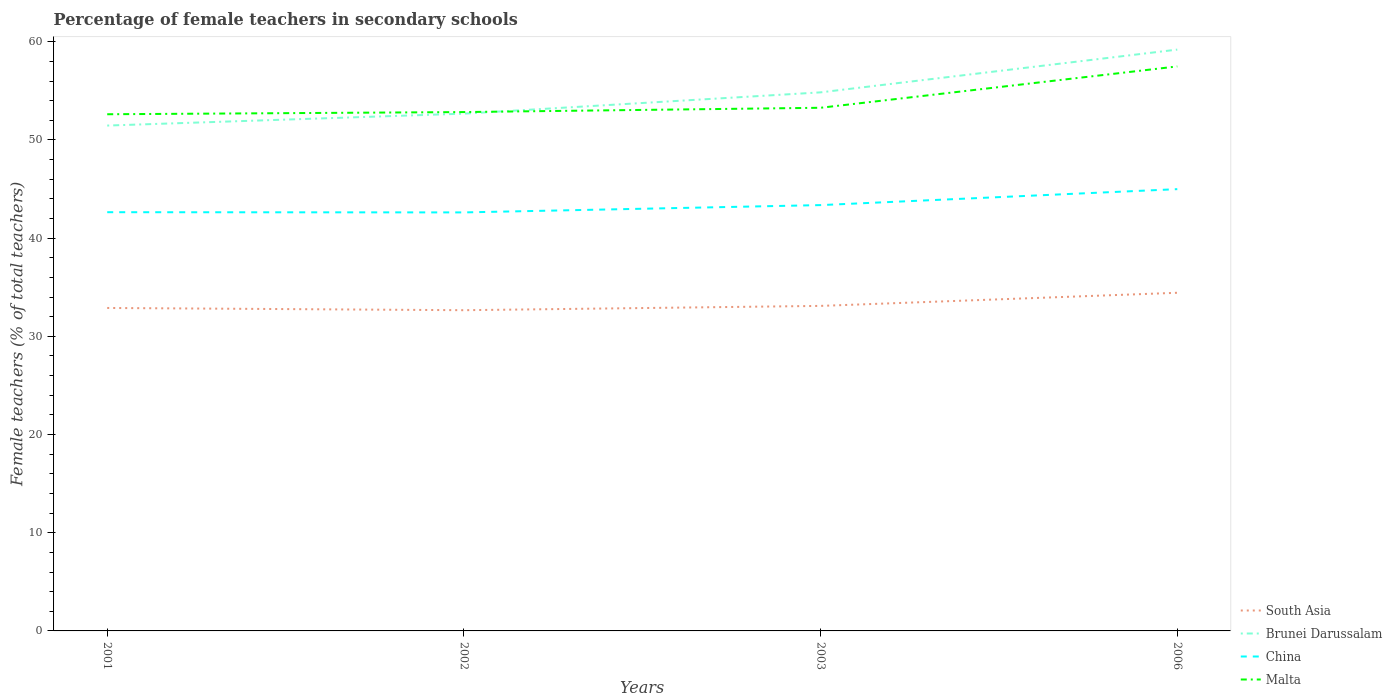How many different coloured lines are there?
Keep it short and to the point. 4. Is the number of lines equal to the number of legend labels?
Offer a very short reply. Yes. Across all years, what is the maximum percentage of female teachers in South Asia?
Your response must be concise. 32.66. What is the total percentage of female teachers in China in the graph?
Provide a short and direct response. -1.62. What is the difference between the highest and the second highest percentage of female teachers in Malta?
Offer a very short reply. 4.87. How many lines are there?
Your answer should be compact. 4. Does the graph contain any zero values?
Your answer should be very brief. No. Does the graph contain grids?
Provide a short and direct response. No. What is the title of the graph?
Give a very brief answer. Percentage of female teachers in secondary schools. Does "Caribbean small states" appear as one of the legend labels in the graph?
Keep it short and to the point. No. What is the label or title of the X-axis?
Your answer should be compact. Years. What is the label or title of the Y-axis?
Give a very brief answer. Female teachers (% of total teachers). What is the Female teachers (% of total teachers) in South Asia in 2001?
Make the answer very short. 32.89. What is the Female teachers (% of total teachers) in Brunei Darussalam in 2001?
Your answer should be compact. 51.47. What is the Female teachers (% of total teachers) in China in 2001?
Ensure brevity in your answer.  42.64. What is the Female teachers (% of total teachers) of Malta in 2001?
Your answer should be compact. 52.62. What is the Female teachers (% of total teachers) of South Asia in 2002?
Your response must be concise. 32.66. What is the Female teachers (% of total teachers) in Brunei Darussalam in 2002?
Your response must be concise. 52.68. What is the Female teachers (% of total teachers) of China in 2002?
Your answer should be very brief. 42.62. What is the Female teachers (% of total teachers) of Malta in 2002?
Provide a short and direct response. 52.84. What is the Female teachers (% of total teachers) in South Asia in 2003?
Provide a succinct answer. 33.1. What is the Female teachers (% of total teachers) in Brunei Darussalam in 2003?
Your answer should be very brief. 54.85. What is the Female teachers (% of total teachers) in China in 2003?
Keep it short and to the point. 43.37. What is the Female teachers (% of total teachers) of Malta in 2003?
Ensure brevity in your answer.  53.28. What is the Female teachers (% of total teachers) of South Asia in 2006?
Offer a terse response. 34.44. What is the Female teachers (% of total teachers) in Brunei Darussalam in 2006?
Offer a terse response. 59.2. What is the Female teachers (% of total teachers) of China in 2006?
Your response must be concise. 44.99. What is the Female teachers (% of total teachers) of Malta in 2006?
Offer a very short reply. 57.49. Across all years, what is the maximum Female teachers (% of total teachers) in South Asia?
Give a very brief answer. 34.44. Across all years, what is the maximum Female teachers (% of total teachers) in Brunei Darussalam?
Offer a very short reply. 59.2. Across all years, what is the maximum Female teachers (% of total teachers) in China?
Provide a succinct answer. 44.99. Across all years, what is the maximum Female teachers (% of total teachers) of Malta?
Ensure brevity in your answer.  57.49. Across all years, what is the minimum Female teachers (% of total teachers) of South Asia?
Offer a terse response. 32.66. Across all years, what is the minimum Female teachers (% of total teachers) in Brunei Darussalam?
Keep it short and to the point. 51.47. Across all years, what is the minimum Female teachers (% of total teachers) of China?
Give a very brief answer. 42.62. Across all years, what is the minimum Female teachers (% of total teachers) of Malta?
Give a very brief answer. 52.62. What is the total Female teachers (% of total teachers) in South Asia in the graph?
Offer a terse response. 133.09. What is the total Female teachers (% of total teachers) of Brunei Darussalam in the graph?
Offer a terse response. 218.19. What is the total Female teachers (% of total teachers) of China in the graph?
Make the answer very short. 173.62. What is the total Female teachers (% of total teachers) in Malta in the graph?
Offer a very short reply. 216.22. What is the difference between the Female teachers (% of total teachers) in South Asia in 2001 and that in 2002?
Ensure brevity in your answer.  0.23. What is the difference between the Female teachers (% of total teachers) of Brunei Darussalam in 2001 and that in 2002?
Provide a short and direct response. -1.21. What is the difference between the Female teachers (% of total teachers) in China in 2001 and that in 2002?
Ensure brevity in your answer.  0.02. What is the difference between the Female teachers (% of total teachers) in Malta in 2001 and that in 2002?
Offer a very short reply. -0.22. What is the difference between the Female teachers (% of total teachers) of South Asia in 2001 and that in 2003?
Keep it short and to the point. -0.21. What is the difference between the Female teachers (% of total teachers) of Brunei Darussalam in 2001 and that in 2003?
Offer a terse response. -3.38. What is the difference between the Female teachers (% of total teachers) of China in 2001 and that in 2003?
Offer a terse response. -0.72. What is the difference between the Female teachers (% of total teachers) of Malta in 2001 and that in 2003?
Your response must be concise. -0.66. What is the difference between the Female teachers (% of total teachers) of South Asia in 2001 and that in 2006?
Ensure brevity in your answer.  -1.55. What is the difference between the Female teachers (% of total teachers) in Brunei Darussalam in 2001 and that in 2006?
Offer a very short reply. -7.74. What is the difference between the Female teachers (% of total teachers) of China in 2001 and that in 2006?
Provide a succinct answer. -2.35. What is the difference between the Female teachers (% of total teachers) of Malta in 2001 and that in 2006?
Make the answer very short. -4.87. What is the difference between the Female teachers (% of total teachers) in South Asia in 2002 and that in 2003?
Provide a short and direct response. -0.44. What is the difference between the Female teachers (% of total teachers) of Brunei Darussalam in 2002 and that in 2003?
Keep it short and to the point. -2.17. What is the difference between the Female teachers (% of total teachers) in China in 2002 and that in 2003?
Keep it short and to the point. -0.74. What is the difference between the Female teachers (% of total teachers) of Malta in 2002 and that in 2003?
Your answer should be very brief. -0.44. What is the difference between the Female teachers (% of total teachers) in South Asia in 2002 and that in 2006?
Provide a short and direct response. -1.77. What is the difference between the Female teachers (% of total teachers) in Brunei Darussalam in 2002 and that in 2006?
Provide a short and direct response. -6.52. What is the difference between the Female teachers (% of total teachers) of China in 2002 and that in 2006?
Your response must be concise. -2.37. What is the difference between the Female teachers (% of total teachers) in Malta in 2002 and that in 2006?
Your response must be concise. -4.65. What is the difference between the Female teachers (% of total teachers) of South Asia in 2003 and that in 2006?
Make the answer very short. -1.34. What is the difference between the Female teachers (% of total teachers) of Brunei Darussalam in 2003 and that in 2006?
Provide a short and direct response. -4.35. What is the difference between the Female teachers (% of total teachers) of China in 2003 and that in 2006?
Ensure brevity in your answer.  -1.62. What is the difference between the Female teachers (% of total teachers) in Malta in 2003 and that in 2006?
Ensure brevity in your answer.  -4.21. What is the difference between the Female teachers (% of total teachers) in South Asia in 2001 and the Female teachers (% of total teachers) in Brunei Darussalam in 2002?
Offer a very short reply. -19.79. What is the difference between the Female teachers (% of total teachers) in South Asia in 2001 and the Female teachers (% of total teachers) in China in 2002?
Ensure brevity in your answer.  -9.73. What is the difference between the Female teachers (% of total teachers) in South Asia in 2001 and the Female teachers (% of total teachers) in Malta in 2002?
Keep it short and to the point. -19.95. What is the difference between the Female teachers (% of total teachers) of Brunei Darussalam in 2001 and the Female teachers (% of total teachers) of China in 2002?
Give a very brief answer. 8.84. What is the difference between the Female teachers (% of total teachers) of Brunei Darussalam in 2001 and the Female teachers (% of total teachers) of Malta in 2002?
Make the answer very short. -1.37. What is the difference between the Female teachers (% of total teachers) of China in 2001 and the Female teachers (% of total teachers) of Malta in 2002?
Make the answer very short. -10.2. What is the difference between the Female teachers (% of total teachers) of South Asia in 2001 and the Female teachers (% of total teachers) of Brunei Darussalam in 2003?
Provide a succinct answer. -21.96. What is the difference between the Female teachers (% of total teachers) in South Asia in 2001 and the Female teachers (% of total teachers) in China in 2003?
Offer a very short reply. -10.48. What is the difference between the Female teachers (% of total teachers) in South Asia in 2001 and the Female teachers (% of total teachers) in Malta in 2003?
Your response must be concise. -20.39. What is the difference between the Female teachers (% of total teachers) in Brunei Darussalam in 2001 and the Female teachers (% of total teachers) in China in 2003?
Your answer should be compact. 8.1. What is the difference between the Female teachers (% of total teachers) of Brunei Darussalam in 2001 and the Female teachers (% of total teachers) of Malta in 2003?
Offer a terse response. -1.81. What is the difference between the Female teachers (% of total teachers) of China in 2001 and the Female teachers (% of total teachers) of Malta in 2003?
Your answer should be compact. -10.63. What is the difference between the Female teachers (% of total teachers) in South Asia in 2001 and the Female teachers (% of total teachers) in Brunei Darussalam in 2006?
Provide a succinct answer. -26.31. What is the difference between the Female teachers (% of total teachers) of South Asia in 2001 and the Female teachers (% of total teachers) of China in 2006?
Your answer should be very brief. -12.1. What is the difference between the Female teachers (% of total teachers) in South Asia in 2001 and the Female teachers (% of total teachers) in Malta in 2006?
Your response must be concise. -24.6. What is the difference between the Female teachers (% of total teachers) of Brunei Darussalam in 2001 and the Female teachers (% of total teachers) of China in 2006?
Make the answer very short. 6.48. What is the difference between the Female teachers (% of total teachers) of Brunei Darussalam in 2001 and the Female teachers (% of total teachers) of Malta in 2006?
Ensure brevity in your answer.  -6.02. What is the difference between the Female teachers (% of total teachers) of China in 2001 and the Female teachers (% of total teachers) of Malta in 2006?
Your answer should be compact. -14.85. What is the difference between the Female teachers (% of total teachers) in South Asia in 2002 and the Female teachers (% of total teachers) in Brunei Darussalam in 2003?
Your response must be concise. -22.19. What is the difference between the Female teachers (% of total teachers) in South Asia in 2002 and the Female teachers (% of total teachers) in China in 2003?
Offer a very short reply. -10.7. What is the difference between the Female teachers (% of total teachers) of South Asia in 2002 and the Female teachers (% of total teachers) of Malta in 2003?
Your answer should be compact. -20.61. What is the difference between the Female teachers (% of total teachers) of Brunei Darussalam in 2002 and the Female teachers (% of total teachers) of China in 2003?
Make the answer very short. 9.31. What is the difference between the Female teachers (% of total teachers) in Brunei Darussalam in 2002 and the Female teachers (% of total teachers) in Malta in 2003?
Your response must be concise. -0.6. What is the difference between the Female teachers (% of total teachers) in China in 2002 and the Female teachers (% of total teachers) in Malta in 2003?
Your answer should be compact. -10.66. What is the difference between the Female teachers (% of total teachers) of South Asia in 2002 and the Female teachers (% of total teachers) of Brunei Darussalam in 2006?
Keep it short and to the point. -26.54. What is the difference between the Female teachers (% of total teachers) of South Asia in 2002 and the Female teachers (% of total teachers) of China in 2006?
Ensure brevity in your answer.  -12.33. What is the difference between the Female teachers (% of total teachers) in South Asia in 2002 and the Female teachers (% of total teachers) in Malta in 2006?
Make the answer very short. -24.83. What is the difference between the Female teachers (% of total teachers) in Brunei Darussalam in 2002 and the Female teachers (% of total teachers) in China in 2006?
Provide a succinct answer. 7.69. What is the difference between the Female teachers (% of total teachers) in Brunei Darussalam in 2002 and the Female teachers (% of total teachers) in Malta in 2006?
Offer a terse response. -4.81. What is the difference between the Female teachers (% of total teachers) in China in 2002 and the Female teachers (% of total teachers) in Malta in 2006?
Give a very brief answer. -14.87. What is the difference between the Female teachers (% of total teachers) of South Asia in 2003 and the Female teachers (% of total teachers) of Brunei Darussalam in 2006?
Your answer should be compact. -26.1. What is the difference between the Female teachers (% of total teachers) of South Asia in 2003 and the Female teachers (% of total teachers) of China in 2006?
Your response must be concise. -11.89. What is the difference between the Female teachers (% of total teachers) in South Asia in 2003 and the Female teachers (% of total teachers) in Malta in 2006?
Offer a terse response. -24.39. What is the difference between the Female teachers (% of total teachers) in Brunei Darussalam in 2003 and the Female teachers (% of total teachers) in China in 2006?
Provide a short and direct response. 9.86. What is the difference between the Female teachers (% of total teachers) of Brunei Darussalam in 2003 and the Female teachers (% of total teachers) of Malta in 2006?
Offer a terse response. -2.64. What is the difference between the Female teachers (% of total teachers) in China in 2003 and the Female teachers (% of total teachers) in Malta in 2006?
Make the answer very short. -14.12. What is the average Female teachers (% of total teachers) in South Asia per year?
Make the answer very short. 33.27. What is the average Female teachers (% of total teachers) in Brunei Darussalam per year?
Offer a terse response. 54.55. What is the average Female teachers (% of total teachers) of China per year?
Offer a terse response. 43.41. What is the average Female teachers (% of total teachers) in Malta per year?
Offer a very short reply. 54.06. In the year 2001, what is the difference between the Female teachers (% of total teachers) in South Asia and Female teachers (% of total teachers) in Brunei Darussalam?
Make the answer very short. -18.58. In the year 2001, what is the difference between the Female teachers (% of total teachers) in South Asia and Female teachers (% of total teachers) in China?
Keep it short and to the point. -9.75. In the year 2001, what is the difference between the Female teachers (% of total teachers) of South Asia and Female teachers (% of total teachers) of Malta?
Provide a short and direct response. -19.73. In the year 2001, what is the difference between the Female teachers (% of total teachers) of Brunei Darussalam and Female teachers (% of total teachers) of China?
Provide a short and direct response. 8.82. In the year 2001, what is the difference between the Female teachers (% of total teachers) in Brunei Darussalam and Female teachers (% of total teachers) in Malta?
Your answer should be compact. -1.15. In the year 2001, what is the difference between the Female teachers (% of total teachers) of China and Female teachers (% of total teachers) of Malta?
Give a very brief answer. -9.97. In the year 2002, what is the difference between the Female teachers (% of total teachers) of South Asia and Female teachers (% of total teachers) of Brunei Darussalam?
Offer a terse response. -20.02. In the year 2002, what is the difference between the Female teachers (% of total teachers) in South Asia and Female teachers (% of total teachers) in China?
Provide a succinct answer. -9.96. In the year 2002, what is the difference between the Female teachers (% of total teachers) in South Asia and Female teachers (% of total teachers) in Malta?
Make the answer very short. -20.18. In the year 2002, what is the difference between the Female teachers (% of total teachers) in Brunei Darussalam and Female teachers (% of total teachers) in China?
Make the answer very short. 10.06. In the year 2002, what is the difference between the Female teachers (% of total teachers) of Brunei Darussalam and Female teachers (% of total teachers) of Malta?
Ensure brevity in your answer.  -0.16. In the year 2002, what is the difference between the Female teachers (% of total teachers) in China and Female teachers (% of total teachers) in Malta?
Ensure brevity in your answer.  -10.22. In the year 2003, what is the difference between the Female teachers (% of total teachers) in South Asia and Female teachers (% of total teachers) in Brunei Darussalam?
Give a very brief answer. -21.75. In the year 2003, what is the difference between the Female teachers (% of total teachers) of South Asia and Female teachers (% of total teachers) of China?
Your answer should be compact. -10.27. In the year 2003, what is the difference between the Female teachers (% of total teachers) of South Asia and Female teachers (% of total teachers) of Malta?
Provide a short and direct response. -20.18. In the year 2003, what is the difference between the Female teachers (% of total teachers) in Brunei Darussalam and Female teachers (% of total teachers) in China?
Your answer should be compact. 11.48. In the year 2003, what is the difference between the Female teachers (% of total teachers) in Brunei Darussalam and Female teachers (% of total teachers) in Malta?
Ensure brevity in your answer.  1.57. In the year 2003, what is the difference between the Female teachers (% of total teachers) in China and Female teachers (% of total teachers) in Malta?
Your answer should be compact. -9.91. In the year 2006, what is the difference between the Female teachers (% of total teachers) of South Asia and Female teachers (% of total teachers) of Brunei Darussalam?
Offer a terse response. -24.76. In the year 2006, what is the difference between the Female teachers (% of total teachers) of South Asia and Female teachers (% of total teachers) of China?
Provide a short and direct response. -10.55. In the year 2006, what is the difference between the Female teachers (% of total teachers) in South Asia and Female teachers (% of total teachers) in Malta?
Keep it short and to the point. -23.05. In the year 2006, what is the difference between the Female teachers (% of total teachers) of Brunei Darussalam and Female teachers (% of total teachers) of China?
Your response must be concise. 14.21. In the year 2006, what is the difference between the Female teachers (% of total teachers) of Brunei Darussalam and Female teachers (% of total teachers) of Malta?
Provide a succinct answer. 1.71. In the year 2006, what is the difference between the Female teachers (% of total teachers) in China and Female teachers (% of total teachers) in Malta?
Offer a terse response. -12.5. What is the ratio of the Female teachers (% of total teachers) in South Asia in 2001 to that in 2002?
Offer a terse response. 1.01. What is the ratio of the Female teachers (% of total teachers) in China in 2001 to that in 2002?
Your answer should be very brief. 1. What is the ratio of the Female teachers (% of total teachers) in Malta in 2001 to that in 2002?
Your response must be concise. 1. What is the ratio of the Female teachers (% of total teachers) in Brunei Darussalam in 2001 to that in 2003?
Your response must be concise. 0.94. What is the ratio of the Female teachers (% of total teachers) of China in 2001 to that in 2003?
Give a very brief answer. 0.98. What is the ratio of the Female teachers (% of total teachers) in Malta in 2001 to that in 2003?
Keep it short and to the point. 0.99. What is the ratio of the Female teachers (% of total teachers) of South Asia in 2001 to that in 2006?
Provide a succinct answer. 0.96. What is the ratio of the Female teachers (% of total teachers) of Brunei Darussalam in 2001 to that in 2006?
Offer a very short reply. 0.87. What is the ratio of the Female teachers (% of total teachers) in China in 2001 to that in 2006?
Offer a very short reply. 0.95. What is the ratio of the Female teachers (% of total teachers) in Malta in 2001 to that in 2006?
Provide a short and direct response. 0.92. What is the ratio of the Female teachers (% of total teachers) of South Asia in 2002 to that in 2003?
Your answer should be very brief. 0.99. What is the ratio of the Female teachers (% of total teachers) in Brunei Darussalam in 2002 to that in 2003?
Your response must be concise. 0.96. What is the ratio of the Female teachers (% of total teachers) in China in 2002 to that in 2003?
Provide a short and direct response. 0.98. What is the ratio of the Female teachers (% of total teachers) in Malta in 2002 to that in 2003?
Your response must be concise. 0.99. What is the ratio of the Female teachers (% of total teachers) of South Asia in 2002 to that in 2006?
Offer a terse response. 0.95. What is the ratio of the Female teachers (% of total teachers) of Brunei Darussalam in 2002 to that in 2006?
Your answer should be compact. 0.89. What is the ratio of the Female teachers (% of total teachers) of China in 2002 to that in 2006?
Give a very brief answer. 0.95. What is the ratio of the Female teachers (% of total teachers) in Malta in 2002 to that in 2006?
Your answer should be compact. 0.92. What is the ratio of the Female teachers (% of total teachers) in South Asia in 2003 to that in 2006?
Provide a short and direct response. 0.96. What is the ratio of the Female teachers (% of total teachers) of Brunei Darussalam in 2003 to that in 2006?
Provide a succinct answer. 0.93. What is the ratio of the Female teachers (% of total teachers) of China in 2003 to that in 2006?
Your response must be concise. 0.96. What is the ratio of the Female teachers (% of total teachers) in Malta in 2003 to that in 2006?
Ensure brevity in your answer.  0.93. What is the difference between the highest and the second highest Female teachers (% of total teachers) of South Asia?
Offer a very short reply. 1.34. What is the difference between the highest and the second highest Female teachers (% of total teachers) of Brunei Darussalam?
Offer a very short reply. 4.35. What is the difference between the highest and the second highest Female teachers (% of total teachers) in China?
Offer a very short reply. 1.62. What is the difference between the highest and the second highest Female teachers (% of total teachers) of Malta?
Offer a terse response. 4.21. What is the difference between the highest and the lowest Female teachers (% of total teachers) of South Asia?
Your answer should be compact. 1.77. What is the difference between the highest and the lowest Female teachers (% of total teachers) of Brunei Darussalam?
Your answer should be very brief. 7.74. What is the difference between the highest and the lowest Female teachers (% of total teachers) of China?
Offer a terse response. 2.37. What is the difference between the highest and the lowest Female teachers (% of total teachers) in Malta?
Ensure brevity in your answer.  4.87. 